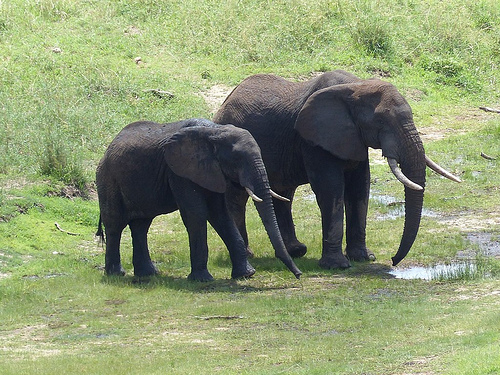Does the baby elephant have gray color and small size? Yes, the baby elephant has a gray color and is of a smaller size compared to the larger elephant next to it. 